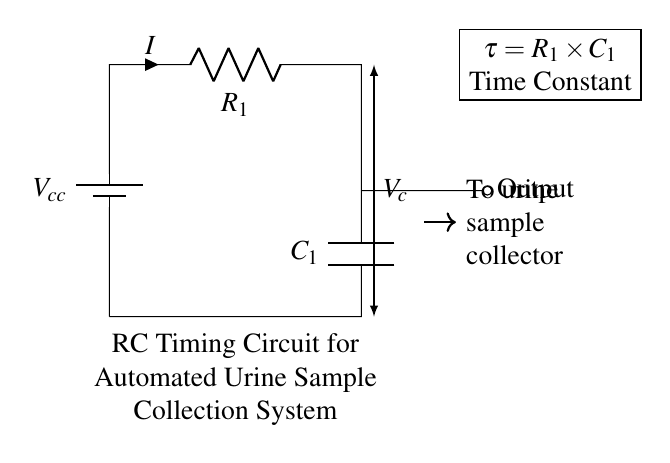What are the components in the circuit? The circuit consists of a battery, a resistor, and a capacitor, which are connected in a series configuration. The battery provides voltage, the resistor limits current, and the capacitor stores charge.
Answer: battery, resistor, capacitor What is the label of the resistor? The resistor in the diagram is labeled as R1, denoting its position and role in the circuit.
Answer: R1 What is the time constant of the RC circuit? The time constant is calculated using the formula tau equals R1 multiplied by C1. The circuit shows that these components are variables that directly affect the timing operation of the system.
Answer: R1 times C1 What does the output signal lead to? The output signal is directed to the urine sample collector, indicating that the timing circuit controls when the sample is collected.
Answer: urine sample collector What is the voltage labeled in the circuit? The voltage across the capacitor is labeled as Vc, which indicates the potential difference across the capacitor over time as it charges and discharges.
Answer: Vc How does the current flow in this circuit? Current flows from the positive terminal of the battery, through the resistor R1, and then into the capacitor C1. This flow continues until the capacitor is fully charged, establishing a relationship between the components.
Answer: from battery to resistor to capacitor What is the role of the capacitor in this circuit? The capacitor in this RC timing circuit functions to store electrical energy temporarily, allowing for timed releases in the output signal, thereby aiding in synchronization for automated urine sample collection.
Answer: store energy 